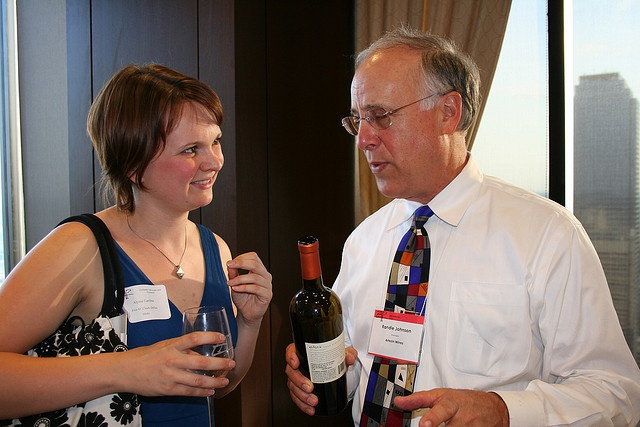Describe the objects in this image and their specific colors. I can see people in gray, lightgray, darkgray, and brown tones, people in gray, brown, black, and maroon tones, handbag in gray, black, and darkgray tones, bottle in gray, black, darkgray, and maroon tones, and tie in gray, black, navy, and maroon tones in this image. 